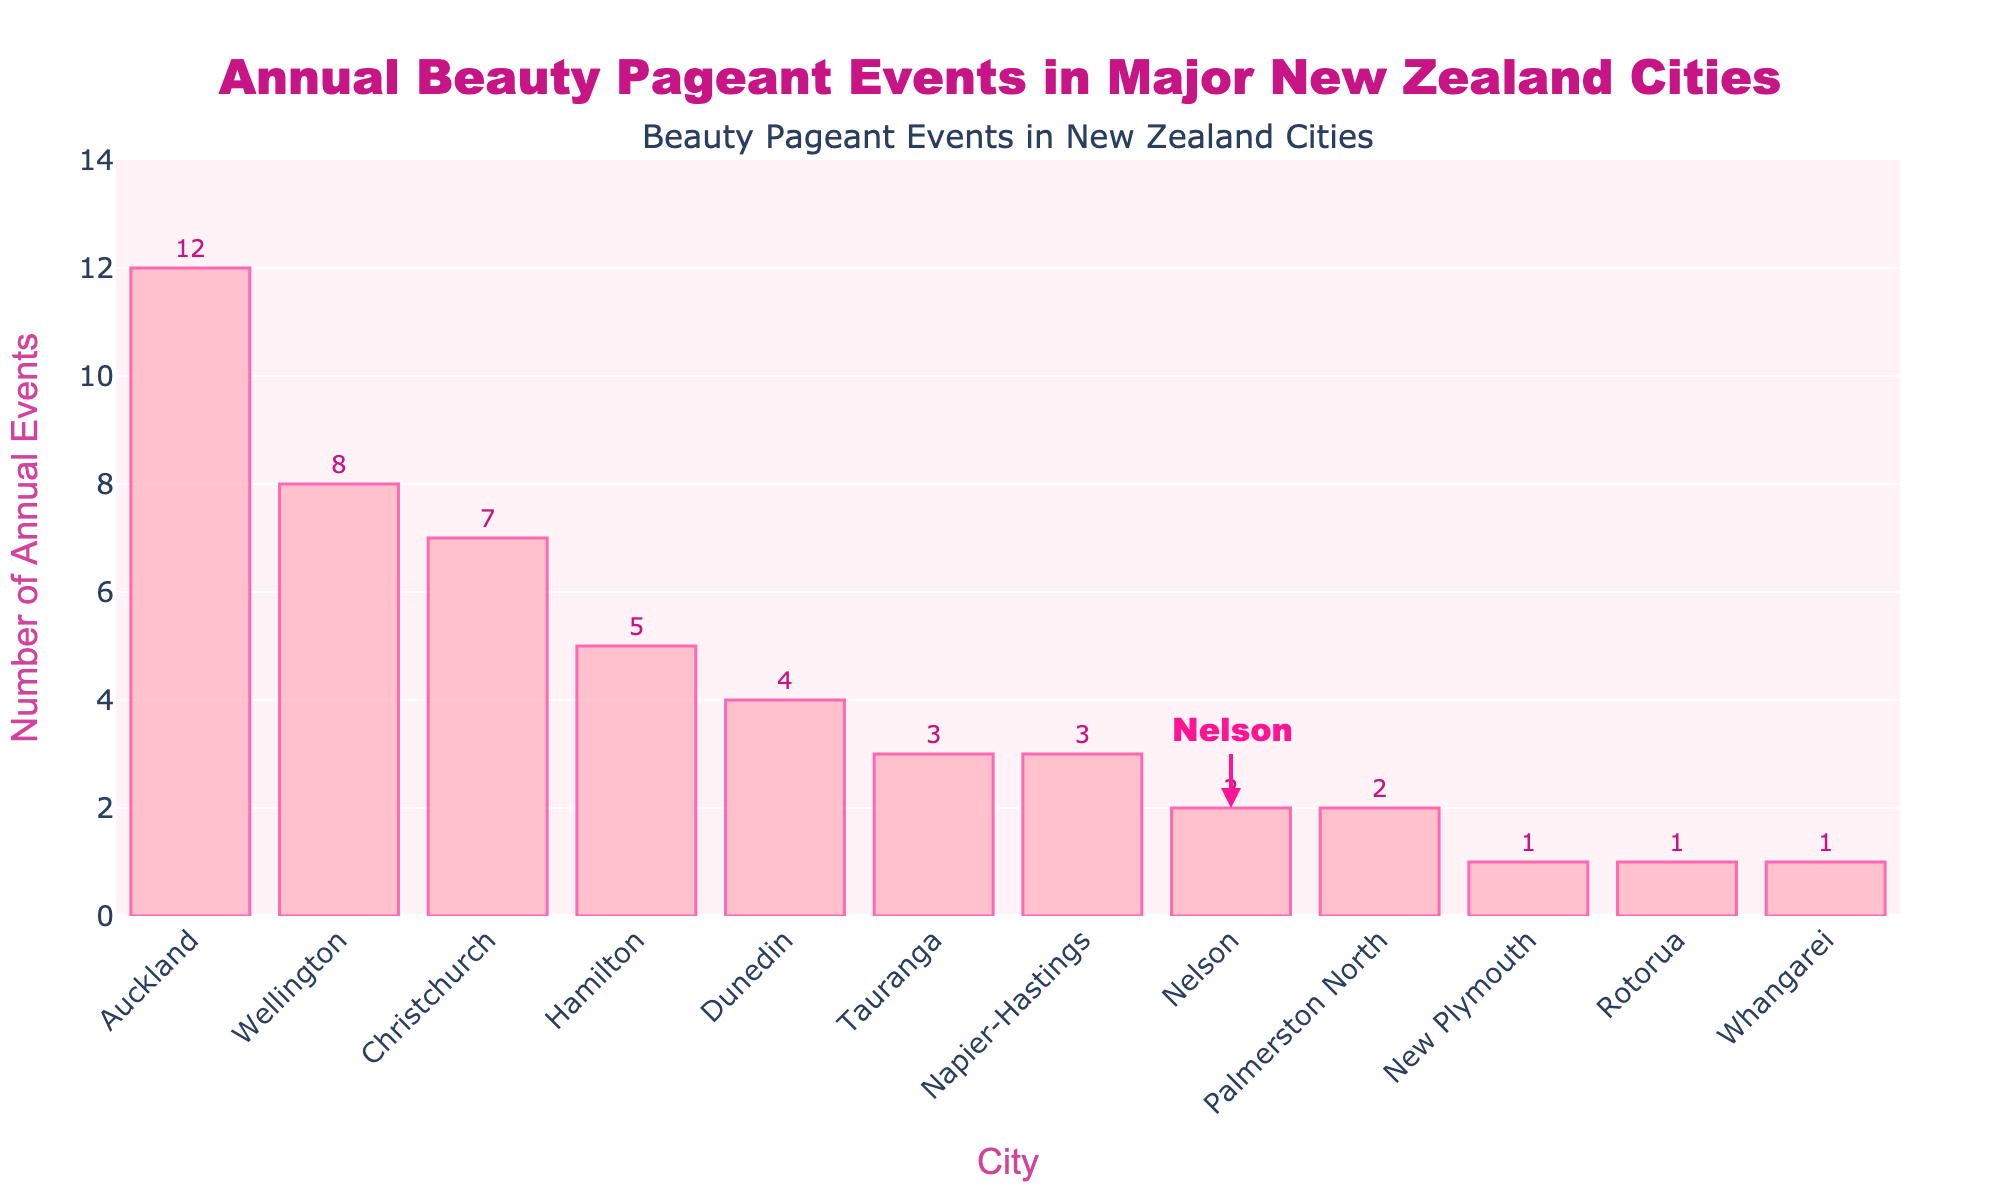Which city holds the most annual beauty pageant events? The tallest bar represents the city with the most events.
Answer: Auckland How many more beauty pageant events are held in Auckland than in Wellington? Subtract the number of events in Wellington from those in Auckland (12 - 8).
Answer: 4 What is the total number of annual beauty pageant events held in Christchurch, Hamilton, and Dunedin combined? Add the number of events in these three cities (7 + 5 + 4).
Answer: 16 Which cities have the same number of annual beauty pageant events? Look for cities with bars of the same height. Nelson and Palmerston North have 2 events each, Napier-Hastings and Tauranga have 3 each, Rotorua, Whangarei, and New Plymouth have 1 each.
Answer: Nelson, Palmerston North; Napier-Hastings, Tauranga; Rotorua, Whangarei, New Plymouth What is the color of the bars representing the number of annual beauty pageant events? Assess the fill color of the bars.
Answer: Light pink What is the height of the bar representing Nelson, and what does it indicate? The bar for Nelson reaches up to 2 and indicates 2 annual events.
Answer: 2 Which city is highlighted with an annotation and arrow? Identify the city marked with an additional annotation.
Answer: Nelson How many total beauty pageant events are held annually in the cities with fewer than 3 events? Add the number of events in Nelson, Palmerston North, New Plymouth, Rotorua, and Whangarei (2 + 2 + 1 + 1 + 1).
Answer: 7 Do Wellington or Christchurch hold more annual beauty pageant events? Compare the heights of the bars for Wellington and Christchurch.
Answer: Wellington What is the average number of beauty pageant events held annually across all cities listed? Sum the number of events in all cities (sum is 49), and divide by the number of cities (12). \( \frac{49}{12} \approx 4.08 \)
Answer: 4.08 